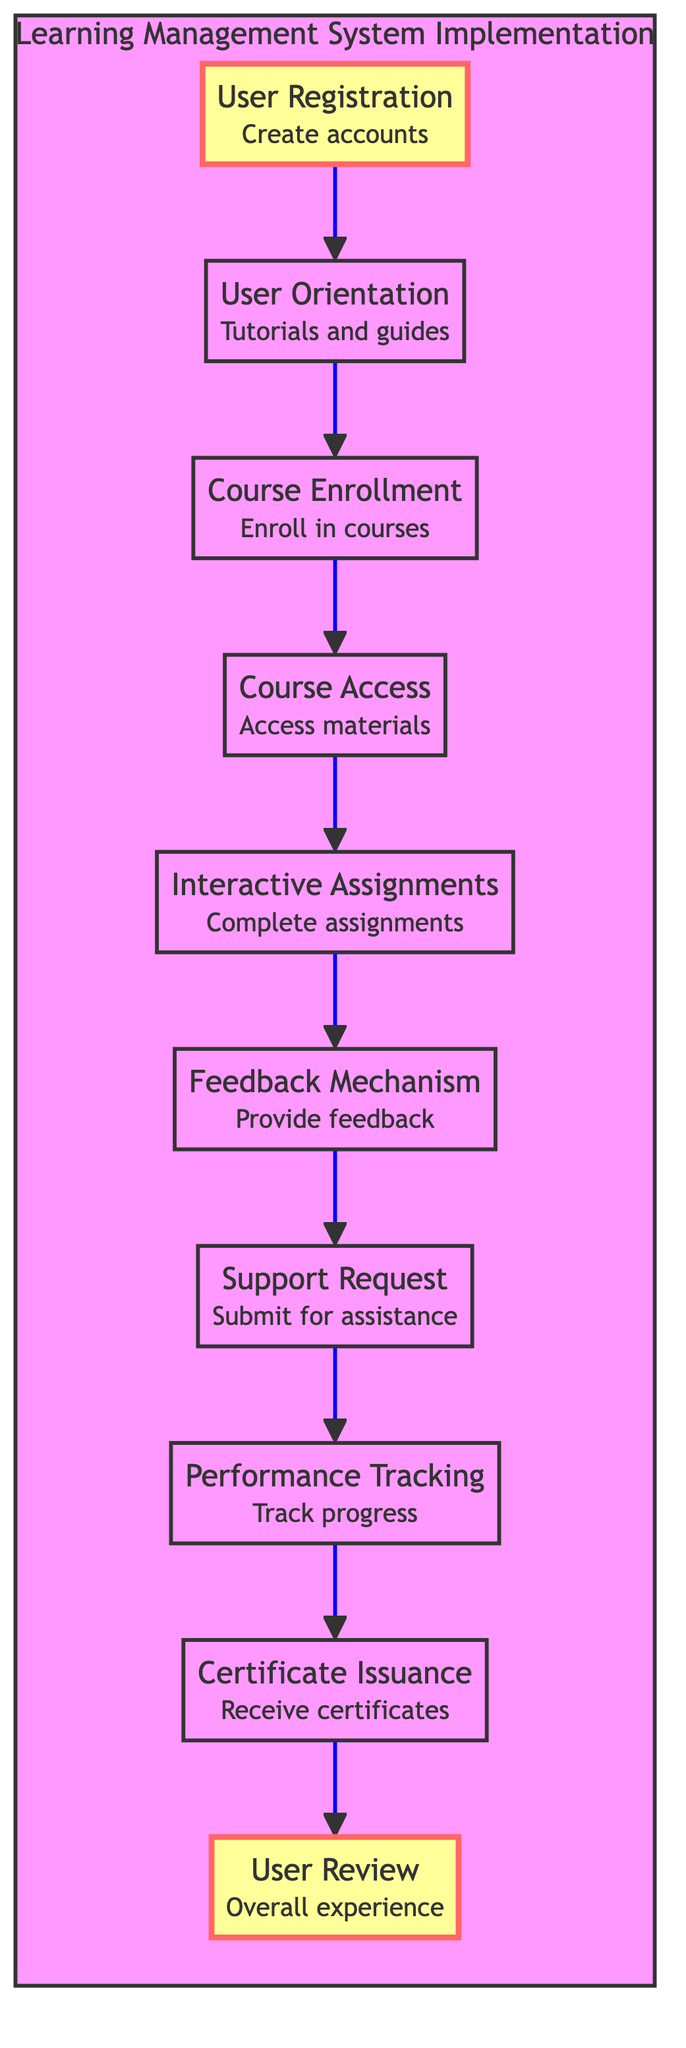What is the first step in the user journey mapping? The first step is indicated by the topmost node in the diagram, which is "User Registration." This defines the starting point of the user journey.
Answer: User Registration How many main nodes are represented in the diagram? By counting all the distinct nodes shown within the implementation section, we find there are ten main nodes detailing various stages of the user journey.
Answer: 10 Which node directly follows the "User Orientation"? "Course Enrollment" follows "User Orientation" and indicates the next action users take after receiving tutorials and guides on how to navigate the LMS.
Answer: Course Enrollment What kind of feedback can users provide in the LMS? Users have a specific mechanism to provide feedback on courses and LMS features, as indicated by the node "Feedback Mechanism."
Answer: Feedback on courses and LMS features What is the final step users take in this journey? The last step shown in the diagram is "User Review," which addresses how users assess their overall experience with the LMS after completing their courses.
Answer: User Review How many connections lead from "Interactive Assignments" to other nodes? There is one connection leading from "Interactive Assignments" to "Feedback Mechanism," showing the flow of actions that follow completing assignments.
Answer: 1 Which two nodes are directly connected to "Support Request"? "Feedback Mechanism" leads to "Support Request" as the previous stage, while "Performance Tracking" follows it, indicating a direct connection to both these nodes.
Answer: Feedback Mechanism and Performance Tracking What do users receive after completing courses successfully? The node "Certificate Issuance" denotes that users will receive certificates upon the successful completion of their enrolled courses.
Answer: Certificates How many intermediate steps are there between "User Registration" and "Certificate Issuance"? By tracking the flow from "User Registration" to "Certificate Issuance," we find there are seven intermediate steps, demonstrating a progressive user experience.
Answer: 7 What is the purpose of the "Performance Tracking" node? "Performance Tracking" serves as a method for users to monitor their progress and grades, allowing them to assess their academic performance within the LMS.
Answer: Track progress and grades 